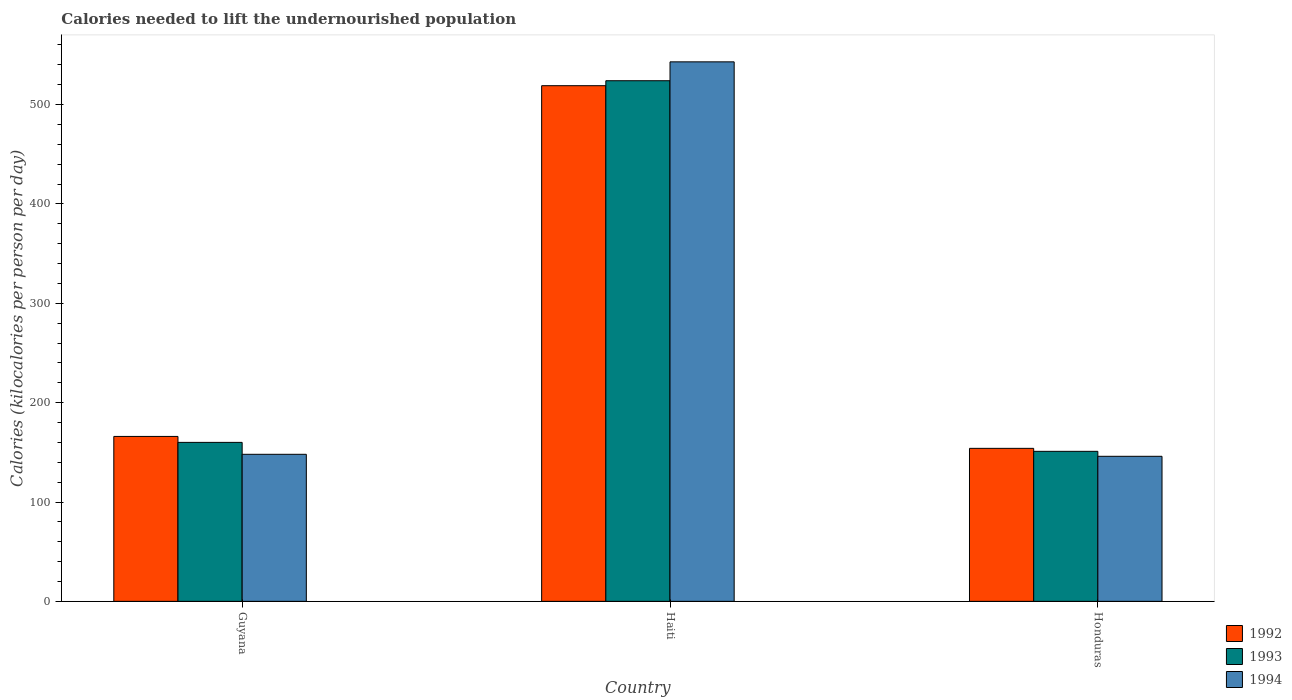How many groups of bars are there?
Keep it short and to the point. 3. Are the number of bars per tick equal to the number of legend labels?
Offer a terse response. Yes. Are the number of bars on each tick of the X-axis equal?
Provide a succinct answer. Yes. What is the label of the 2nd group of bars from the left?
Make the answer very short. Haiti. What is the total calories needed to lift the undernourished population in 1994 in Honduras?
Provide a short and direct response. 146. Across all countries, what is the maximum total calories needed to lift the undernourished population in 1992?
Provide a short and direct response. 519. Across all countries, what is the minimum total calories needed to lift the undernourished population in 1992?
Keep it short and to the point. 154. In which country was the total calories needed to lift the undernourished population in 1993 maximum?
Offer a terse response. Haiti. In which country was the total calories needed to lift the undernourished population in 1993 minimum?
Give a very brief answer. Honduras. What is the total total calories needed to lift the undernourished population in 1994 in the graph?
Your answer should be compact. 837. What is the difference between the total calories needed to lift the undernourished population in 1994 in Guyana and that in Haiti?
Your response must be concise. -395. What is the difference between the total calories needed to lift the undernourished population in 1992 in Honduras and the total calories needed to lift the undernourished population in 1993 in Guyana?
Your response must be concise. -6. What is the average total calories needed to lift the undernourished population in 1994 per country?
Your answer should be compact. 279. What is the difference between the total calories needed to lift the undernourished population of/in 1993 and total calories needed to lift the undernourished population of/in 1992 in Guyana?
Ensure brevity in your answer.  -6. What is the ratio of the total calories needed to lift the undernourished population in 1992 in Haiti to that in Honduras?
Provide a succinct answer. 3.37. Is the total calories needed to lift the undernourished population in 1993 in Guyana less than that in Honduras?
Your answer should be compact. No. Is the difference between the total calories needed to lift the undernourished population in 1993 in Haiti and Honduras greater than the difference between the total calories needed to lift the undernourished population in 1992 in Haiti and Honduras?
Your response must be concise. Yes. What is the difference between the highest and the second highest total calories needed to lift the undernourished population in 1992?
Provide a short and direct response. -12. What is the difference between the highest and the lowest total calories needed to lift the undernourished population in 1994?
Your response must be concise. 397. In how many countries, is the total calories needed to lift the undernourished population in 1994 greater than the average total calories needed to lift the undernourished population in 1994 taken over all countries?
Give a very brief answer. 1. Is the sum of the total calories needed to lift the undernourished population in 1994 in Guyana and Haiti greater than the maximum total calories needed to lift the undernourished population in 1993 across all countries?
Your answer should be very brief. Yes. What does the 1st bar from the right in Haiti represents?
Offer a very short reply. 1994. How many bars are there?
Ensure brevity in your answer.  9. Are all the bars in the graph horizontal?
Make the answer very short. No. How many countries are there in the graph?
Make the answer very short. 3. What is the difference between two consecutive major ticks on the Y-axis?
Provide a succinct answer. 100. Are the values on the major ticks of Y-axis written in scientific E-notation?
Offer a very short reply. No. Where does the legend appear in the graph?
Keep it short and to the point. Bottom right. How many legend labels are there?
Ensure brevity in your answer.  3. What is the title of the graph?
Your answer should be very brief. Calories needed to lift the undernourished population. What is the label or title of the X-axis?
Make the answer very short. Country. What is the label or title of the Y-axis?
Your response must be concise. Calories (kilocalories per person per day). What is the Calories (kilocalories per person per day) of 1992 in Guyana?
Your response must be concise. 166. What is the Calories (kilocalories per person per day) in 1993 in Guyana?
Keep it short and to the point. 160. What is the Calories (kilocalories per person per day) in 1994 in Guyana?
Give a very brief answer. 148. What is the Calories (kilocalories per person per day) in 1992 in Haiti?
Offer a very short reply. 519. What is the Calories (kilocalories per person per day) in 1993 in Haiti?
Offer a very short reply. 524. What is the Calories (kilocalories per person per day) of 1994 in Haiti?
Offer a very short reply. 543. What is the Calories (kilocalories per person per day) in 1992 in Honduras?
Your answer should be very brief. 154. What is the Calories (kilocalories per person per day) in 1993 in Honduras?
Offer a very short reply. 151. What is the Calories (kilocalories per person per day) of 1994 in Honduras?
Give a very brief answer. 146. Across all countries, what is the maximum Calories (kilocalories per person per day) in 1992?
Provide a succinct answer. 519. Across all countries, what is the maximum Calories (kilocalories per person per day) of 1993?
Your answer should be compact. 524. Across all countries, what is the maximum Calories (kilocalories per person per day) in 1994?
Your answer should be very brief. 543. Across all countries, what is the minimum Calories (kilocalories per person per day) in 1992?
Your answer should be compact. 154. Across all countries, what is the minimum Calories (kilocalories per person per day) in 1993?
Make the answer very short. 151. Across all countries, what is the minimum Calories (kilocalories per person per day) of 1994?
Provide a succinct answer. 146. What is the total Calories (kilocalories per person per day) of 1992 in the graph?
Ensure brevity in your answer.  839. What is the total Calories (kilocalories per person per day) in 1993 in the graph?
Make the answer very short. 835. What is the total Calories (kilocalories per person per day) of 1994 in the graph?
Offer a very short reply. 837. What is the difference between the Calories (kilocalories per person per day) in 1992 in Guyana and that in Haiti?
Give a very brief answer. -353. What is the difference between the Calories (kilocalories per person per day) in 1993 in Guyana and that in Haiti?
Your answer should be very brief. -364. What is the difference between the Calories (kilocalories per person per day) of 1994 in Guyana and that in Haiti?
Your answer should be very brief. -395. What is the difference between the Calories (kilocalories per person per day) in 1993 in Guyana and that in Honduras?
Keep it short and to the point. 9. What is the difference between the Calories (kilocalories per person per day) of 1992 in Haiti and that in Honduras?
Give a very brief answer. 365. What is the difference between the Calories (kilocalories per person per day) in 1993 in Haiti and that in Honduras?
Provide a succinct answer. 373. What is the difference between the Calories (kilocalories per person per day) in 1994 in Haiti and that in Honduras?
Provide a short and direct response. 397. What is the difference between the Calories (kilocalories per person per day) in 1992 in Guyana and the Calories (kilocalories per person per day) in 1993 in Haiti?
Offer a terse response. -358. What is the difference between the Calories (kilocalories per person per day) in 1992 in Guyana and the Calories (kilocalories per person per day) in 1994 in Haiti?
Provide a short and direct response. -377. What is the difference between the Calories (kilocalories per person per day) in 1993 in Guyana and the Calories (kilocalories per person per day) in 1994 in Haiti?
Make the answer very short. -383. What is the difference between the Calories (kilocalories per person per day) in 1992 in Guyana and the Calories (kilocalories per person per day) in 1993 in Honduras?
Your answer should be very brief. 15. What is the difference between the Calories (kilocalories per person per day) of 1992 in Guyana and the Calories (kilocalories per person per day) of 1994 in Honduras?
Ensure brevity in your answer.  20. What is the difference between the Calories (kilocalories per person per day) in 1993 in Guyana and the Calories (kilocalories per person per day) in 1994 in Honduras?
Your answer should be compact. 14. What is the difference between the Calories (kilocalories per person per day) of 1992 in Haiti and the Calories (kilocalories per person per day) of 1993 in Honduras?
Offer a terse response. 368. What is the difference between the Calories (kilocalories per person per day) in 1992 in Haiti and the Calories (kilocalories per person per day) in 1994 in Honduras?
Ensure brevity in your answer.  373. What is the difference between the Calories (kilocalories per person per day) of 1993 in Haiti and the Calories (kilocalories per person per day) of 1994 in Honduras?
Your answer should be compact. 378. What is the average Calories (kilocalories per person per day) in 1992 per country?
Your answer should be compact. 279.67. What is the average Calories (kilocalories per person per day) in 1993 per country?
Keep it short and to the point. 278.33. What is the average Calories (kilocalories per person per day) in 1994 per country?
Provide a short and direct response. 279. What is the difference between the Calories (kilocalories per person per day) in 1992 and Calories (kilocalories per person per day) in 1993 in Haiti?
Provide a short and direct response. -5. What is the difference between the Calories (kilocalories per person per day) of 1992 and Calories (kilocalories per person per day) of 1994 in Haiti?
Your answer should be compact. -24. What is the difference between the Calories (kilocalories per person per day) in 1992 and Calories (kilocalories per person per day) in 1993 in Honduras?
Offer a terse response. 3. What is the difference between the Calories (kilocalories per person per day) of 1992 and Calories (kilocalories per person per day) of 1994 in Honduras?
Provide a short and direct response. 8. What is the ratio of the Calories (kilocalories per person per day) in 1992 in Guyana to that in Haiti?
Ensure brevity in your answer.  0.32. What is the ratio of the Calories (kilocalories per person per day) of 1993 in Guyana to that in Haiti?
Keep it short and to the point. 0.31. What is the ratio of the Calories (kilocalories per person per day) of 1994 in Guyana to that in Haiti?
Provide a succinct answer. 0.27. What is the ratio of the Calories (kilocalories per person per day) in 1992 in Guyana to that in Honduras?
Make the answer very short. 1.08. What is the ratio of the Calories (kilocalories per person per day) of 1993 in Guyana to that in Honduras?
Offer a terse response. 1.06. What is the ratio of the Calories (kilocalories per person per day) in 1994 in Guyana to that in Honduras?
Ensure brevity in your answer.  1.01. What is the ratio of the Calories (kilocalories per person per day) of 1992 in Haiti to that in Honduras?
Offer a terse response. 3.37. What is the ratio of the Calories (kilocalories per person per day) of 1993 in Haiti to that in Honduras?
Provide a short and direct response. 3.47. What is the ratio of the Calories (kilocalories per person per day) of 1994 in Haiti to that in Honduras?
Ensure brevity in your answer.  3.72. What is the difference between the highest and the second highest Calories (kilocalories per person per day) of 1992?
Provide a short and direct response. 353. What is the difference between the highest and the second highest Calories (kilocalories per person per day) in 1993?
Offer a terse response. 364. What is the difference between the highest and the second highest Calories (kilocalories per person per day) in 1994?
Keep it short and to the point. 395. What is the difference between the highest and the lowest Calories (kilocalories per person per day) of 1992?
Your response must be concise. 365. What is the difference between the highest and the lowest Calories (kilocalories per person per day) in 1993?
Offer a terse response. 373. What is the difference between the highest and the lowest Calories (kilocalories per person per day) in 1994?
Provide a short and direct response. 397. 